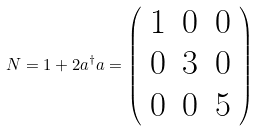Convert formula to latex. <formula><loc_0><loc_0><loc_500><loc_500>N = 1 + 2 a ^ { \dagger } a = \left ( \begin{array} { c c c } 1 & 0 & 0 \\ 0 & 3 & 0 \\ 0 & 0 & 5 \end{array} \right )</formula> 